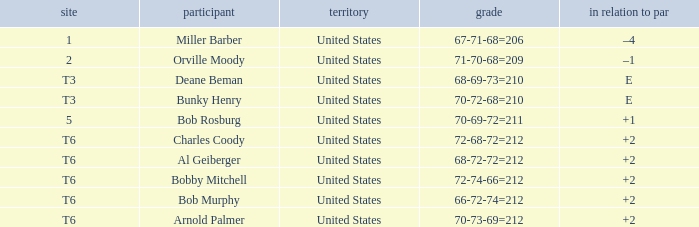What is the score of player bob rosburg? 70-69-72=211. 